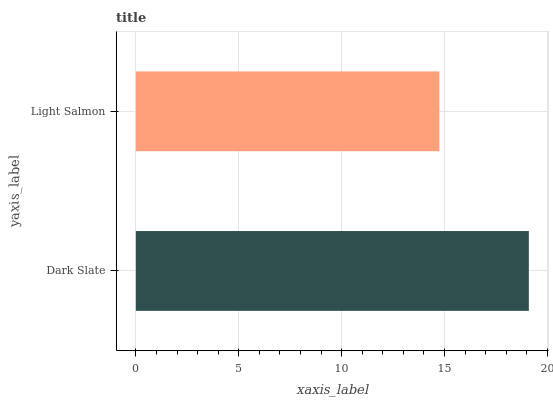Is Light Salmon the minimum?
Answer yes or no. Yes. Is Dark Slate the maximum?
Answer yes or no. Yes. Is Light Salmon the maximum?
Answer yes or no. No. Is Dark Slate greater than Light Salmon?
Answer yes or no. Yes. Is Light Salmon less than Dark Slate?
Answer yes or no. Yes. Is Light Salmon greater than Dark Slate?
Answer yes or no. No. Is Dark Slate less than Light Salmon?
Answer yes or no. No. Is Dark Slate the high median?
Answer yes or no. Yes. Is Light Salmon the low median?
Answer yes or no. Yes. Is Light Salmon the high median?
Answer yes or no. No. Is Dark Slate the low median?
Answer yes or no. No. 